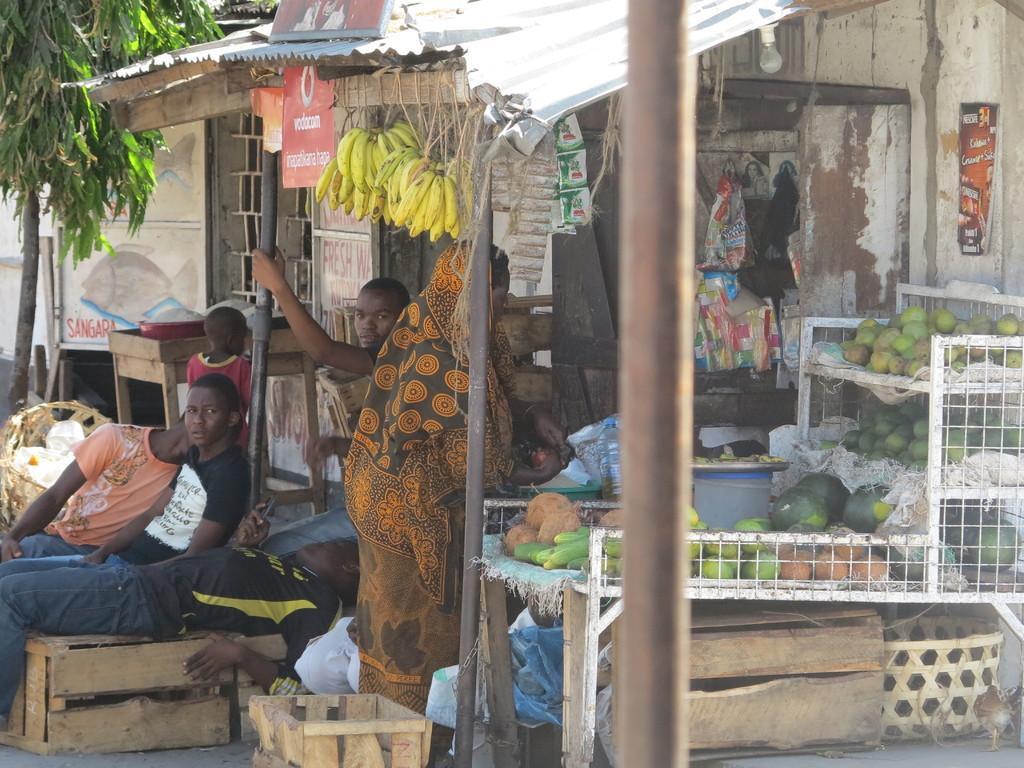Describe this image in one or two sentences. In this image I can see a shop , in the shop I can see persons , boxes, fruits and packets and beside the shop I can see tree. 